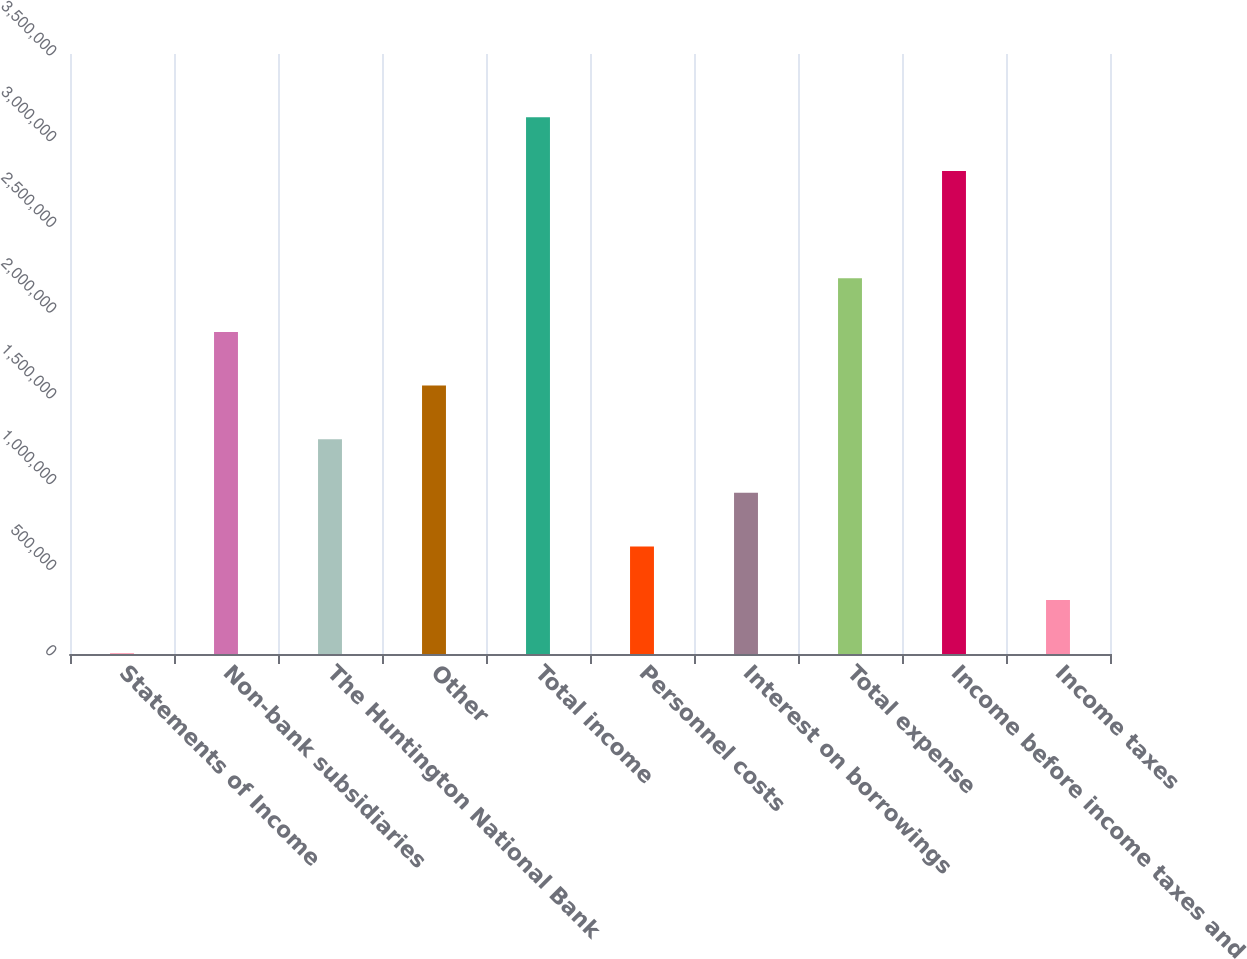Convert chart to OTSL. <chart><loc_0><loc_0><loc_500><loc_500><bar_chart><fcel>Statements of Income<fcel>Non-bank subsidiaries<fcel>The Huntington National Bank<fcel>Other<fcel>Total income<fcel>Personnel costs<fcel>Interest on borrowings<fcel>Total expense<fcel>Income before income taxes and<fcel>Income taxes<nl><fcel>2009<fcel>1.879e+06<fcel>1.25334e+06<fcel>1.56617e+06<fcel>3.13033e+06<fcel>627673<fcel>940505<fcel>2.19183e+06<fcel>2.8175e+06<fcel>314841<nl></chart> 